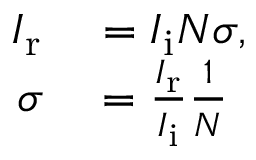<formula> <loc_0><loc_0><loc_500><loc_500>\begin{array} { r l } { I _ { r } } & = I _ { i } N \sigma , } \\ { \sigma } & = { \frac { I _ { r } } { I _ { i } } } { \frac { 1 } { N } } } \end{array}</formula> 